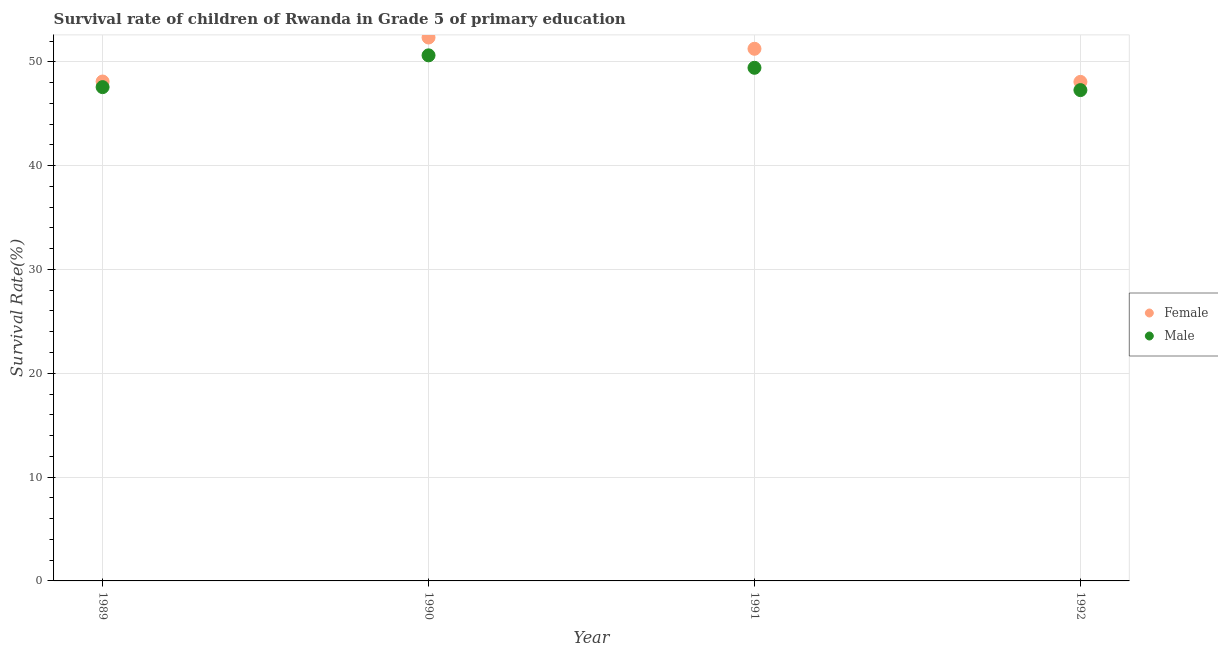How many different coloured dotlines are there?
Keep it short and to the point. 2. What is the survival rate of male students in primary education in 1992?
Keep it short and to the point. 47.27. Across all years, what is the maximum survival rate of female students in primary education?
Ensure brevity in your answer.  52.34. Across all years, what is the minimum survival rate of male students in primary education?
Your answer should be compact. 47.27. In which year was the survival rate of male students in primary education maximum?
Your response must be concise. 1990. In which year was the survival rate of male students in primary education minimum?
Provide a succinct answer. 1992. What is the total survival rate of female students in primary education in the graph?
Keep it short and to the point. 199.75. What is the difference between the survival rate of female students in primary education in 1989 and that in 1990?
Your answer should be compact. -4.24. What is the difference between the survival rate of female students in primary education in 1989 and the survival rate of male students in primary education in 1992?
Your response must be concise. 0.83. What is the average survival rate of male students in primary education per year?
Keep it short and to the point. 48.72. In the year 1991, what is the difference between the survival rate of male students in primary education and survival rate of female students in primary education?
Give a very brief answer. -1.83. In how many years, is the survival rate of female students in primary education greater than 38 %?
Provide a short and direct response. 4. What is the ratio of the survival rate of female students in primary education in 1989 to that in 1990?
Offer a terse response. 0.92. Is the survival rate of female students in primary education in 1990 less than that in 1991?
Your answer should be compact. No. Is the difference between the survival rate of male students in primary education in 1991 and 1992 greater than the difference between the survival rate of female students in primary education in 1991 and 1992?
Provide a succinct answer. No. What is the difference between the highest and the second highest survival rate of male students in primary education?
Give a very brief answer. 1.2. What is the difference between the highest and the lowest survival rate of male students in primary education?
Offer a terse response. 3.35. Does the survival rate of female students in primary education monotonically increase over the years?
Offer a very short reply. No. How many years are there in the graph?
Provide a succinct answer. 4. What is the difference between two consecutive major ticks on the Y-axis?
Your response must be concise. 10. Are the values on the major ticks of Y-axis written in scientific E-notation?
Your answer should be compact. No. How many legend labels are there?
Your answer should be very brief. 2. What is the title of the graph?
Keep it short and to the point. Survival rate of children of Rwanda in Grade 5 of primary education. What is the label or title of the Y-axis?
Provide a succinct answer. Survival Rate(%). What is the Survival Rate(%) of Female in 1989?
Keep it short and to the point. 48.1. What is the Survival Rate(%) of Male in 1989?
Provide a succinct answer. 47.56. What is the Survival Rate(%) in Female in 1990?
Make the answer very short. 52.34. What is the Survival Rate(%) of Male in 1990?
Ensure brevity in your answer.  50.62. What is the Survival Rate(%) of Female in 1991?
Your response must be concise. 51.25. What is the Survival Rate(%) of Male in 1991?
Offer a terse response. 49.42. What is the Survival Rate(%) in Female in 1992?
Keep it short and to the point. 48.06. What is the Survival Rate(%) in Male in 1992?
Your answer should be very brief. 47.27. Across all years, what is the maximum Survival Rate(%) of Female?
Your answer should be very brief. 52.34. Across all years, what is the maximum Survival Rate(%) of Male?
Offer a very short reply. 50.62. Across all years, what is the minimum Survival Rate(%) of Female?
Your answer should be compact. 48.06. Across all years, what is the minimum Survival Rate(%) of Male?
Provide a short and direct response. 47.27. What is the total Survival Rate(%) of Female in the graph?
Your answer should be very brief. 199.75. What is the total Survival Rate(%) in Male in the graph?
Offer a very short reply. 194.87. What is the difference between the Survival Rate(%) in Female in 1989 and that in 1990?
Make the answer very short. -4.24. What is the difference between the Survival Rate(%) in Male in 1989 and that in 1990?
Give a very brief answer. -3.06. What is the difference between the Survival Rate(%) in Female in 1989 and that in 1991?
Provide a short and direct response. -3.15. What is the difference between the Survival Rate(%) of Male in 1989 and that in 1991?
Your answer should be compact. -1.86. What is the difference between the Survival Rate(%) of Female in 1989 and that in 1992?
Provide a succinct answer. 0.03. What is the difference between the Survival Rate(%) of Male in 1989 and that in 1992?
Give a very brief answer. 0.29. What is the difference between the Survival Rate(%) in Female in 1990 and that in 1991?
Your response must be concise. 1.09. What is the difference between the Survival Rate(%) of Male in 1990 and that in 1991?
Keep it short and to the point. 1.2. What is the difference between the Survival Rate(%) in Female in 1990 and that in 1992?
Your response must be concise. 4.27. What is the difference between the Survival Rate(%) in Male in 1990 and that in 1992?
Offer a very short reply. 3.35. What is the difference between the Survival Rate(%) of Female in 1991 and that in 1992?
Provide a succinct answer. 3.19. What is the difference between the Survival Rate(%) in Male in 1991 and that in 1992?
Your answer should be very brief. 2.15. What is the difference between the Survival Rate(%) in Female in 1989 and the Survival Rate(%) in Male in 1990?
Make the answer very short. -2.52. What is the difference between the Survival Rate(%) of Female in 1989 and the Survival Rate(%) of Male in 1991?
Provide a succinct answer. -1.32. What is the difference between the Survival Rate(%) of Female in 1989 and the Survival Rate(%) of Male in 1992?
Provide a succinct answer. 0.83. What is the difference between the Survival Rate(%) in Female in 1990 and the Survival Rate(%) in Male in 1991?
Provide a succinct answer. 2.92. What is the difference between the Survival Rate(%) in Female in 1990 and the Survival Rate(%) in Male in 1992?
Provide a short and direct response. 5.07. What is the difference between the Survival Rate(%) of Female in 1991 and the Survival Rate(%) of Male in 1992?
Offer a terse response. 3.98. What is the average Survival Rate(%) in Female per year?
Keep it short and to the point. 49.94. What is the average Survival Rate(%) of Male per year?
Provide a succinct answer. 48.72. In the year 1989, what is the difference between the Survival Rate(%) in Female and Survival Rate(%) in Male?
Ensure brevity in your answer.  0.54. In the year 1990, what is the difference between the Survival Rate(%) in Female and Survival Rate(%) in Male?
Offer a terse response. 1.72. In the year 1991, what is the difference between the Survival Rate(%) of Female and Survival Rate(%) of Male?
Your answer should be very brief. 1.83. In the year 1992, what is the difference between the Survival Rate(%) in Female and Survival Rate(%) in Male?
Offer a very short reply. 0.79. What is the ratio of the Survival Rate(%) of Female in 1989 to that in 1990?
Your answer should be very brief. 0.92. What is the ratio of the Survival Rate(%) in Male in 1989 to that in 1990?
Your answer should be compact. 0.94. What is the ratio of the Survival Rate(%) in Female in 1989 to that in 1991?
Your response must be concise. 0.94. What is the ratio of the Survival Rate(%) of Male in 1989 to that in 1991?
Your answer should be compact. 0.96. What is the ratio of the Survival Rate(%) in Female in 1989 to that in 1992?
Give a very brief answer. 1. What is the ratio of the Survival Rate(%) of Male in 1989 to that in 1992?
Give a very brief answer. 1.01. What is the ratio of the Survival Rate(%) of Female in 1990 to that in 1991?
Provide a succinct answer. 1.02. What is the ratio of the Survival Rate(%) of Male in 1990 to that in 1991?
Give a very brief answer. 1.02. What is the ratio of the Survival Rate(%) in Female in 1990 to that in 1992?
Your response must be concise. 1.09. What is the ratio of the Survival Rate(%) in Male in 1990 to that in 1992?
Keep it short and to the point. 1.07. What is the ratio of the Survival Rate(%) of Female in 1991 to that in 1992?
Your answer should be compact. 1.07. What is the ratio of the Survival Rate(%) of Male in 1991 to that in 1992?
Ensure brevity in your answer.  1.05. What is the difference between the highest and the second highest Survival Rate(%) in Female?
Your answer should be very brief. 1.09. What is the difference between the highest and the second highest Survival Rate(%) in Male?
Keep it short and to the point. 1.2. What is the difference between the highest and the lowest Survival Rate(%) in Female?
Ensure brevity in your answer.  4.27. What is the difference between the highest and the lowest Survival Rate(%) in Male?
Your answer should be very brief. 3.35. 